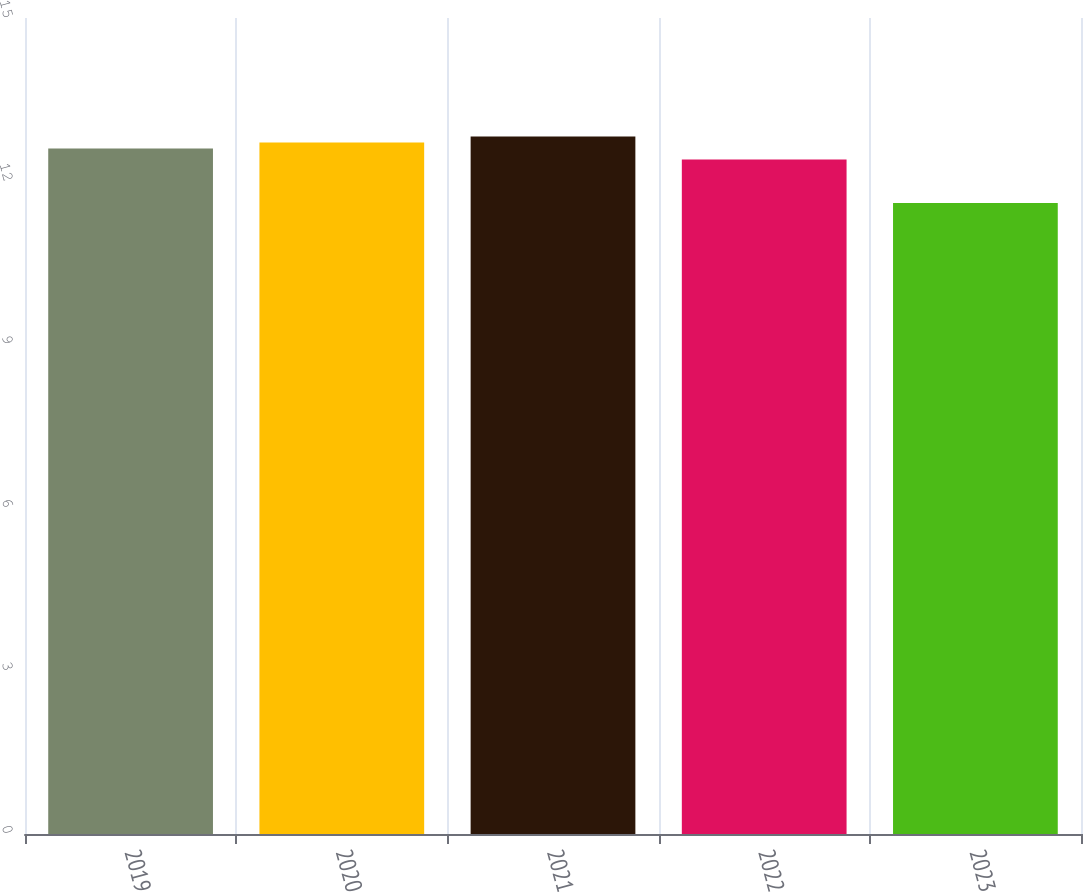<chart> <loc_0><loc_0><loc_500><loc_500><bar_chart><fcel>2019<fcel>2020<fcel>2021<fcel>2022<fcel>2023<nl><fcel>12.6<fcel>12.71<fcel>12.82<fcel>12.4<fcel>11.6<nl></chart> 